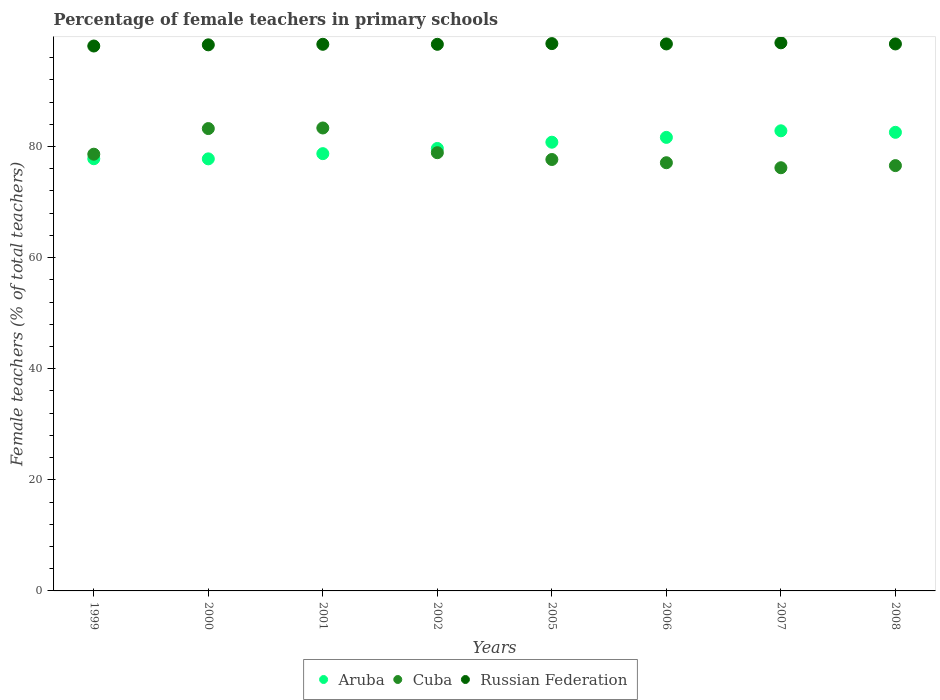Is the number of dotlines equal to the number of legend labels?
Ensure brevity in your answer.  Yes. What is the percentage of female teachers in Aruba in 2005?
Ensure brevity in your answer.  80.78. Across all years, what is the maximum percentage of female teachers in Cuba?
Ensure brevity in your answer.  83.34. Across all years, what is the minimum percentage of female teachers in Aruba?
Your answer should be very brief. 77.78. In which year was the percentage of female teachers in Cuba maximum?
Keep it short and to the point. 2001. What is the total percentage of female teachers in Cuba in the graph?
Provide a succinct answer. 631.56. What is the difference between the percentage of female teachers in Russian Federation in 2002 and that in 2005?
Give a very brief answer. -0.13. What is the difference between the percentage of female teachers in Cuba in 1999 and the percentage of female teachers in Russian Federation in 2005?
Offer a terse response. -19.91. What is the average percentage of female teachers in Russian Federation per year?
Make the answer very short. 98.42. In the year 2000, what is the difference between the percentage of female teachers in Russian Federation and percentage of female teachers in Cuba?
Your answer should be compact. 15.07. In how many years, is the percentage of female teachers in Cuba greater than 88 %?
Your response must be concise. 0. What is the ratio of the percentage of female teachers in Russian Federation in 2002 to that in 2005?
Your answer should be compact. 1. Is the percentage of female teachers in Cuba in 1999 less than that in 2002?
Make the answer very short. Yes. Is the difference between the percentage of female teachers in Russian Federation in 2005 and 2007 greater than the difference between the percentage of female teachers in Cuba in 2005 and 2007?
Offer a terse response. No. What is the difference between the highest and the second highest percentage of female teachers in Cuba?
Your response must be concise. 0.11. What is the difference between the highest and the lowest percentage of female teachers in Aruba?
Give a very brief answer. 5.05. Is the sum of the percentage of female teachers in Russian Federation in 1999 and 2000 greater than the maximum percentage of female teachers in Cuba across all years?
Give a very brief answer. Yes. Is it the case that in every year, the sum of the percentage of female teachers in Russian Federation and percentage of female teachers in Aruba  is greater than the percentage of female teachers in Cuba?
Your answer should be very brief. Yes. Does the percentage of female teachers in Aruba monotonically increase over the years?
Provide a succinct answer. No. Is the percentage of female teachers in Cuba strictly less than the percentage of female teachers in Aruba over the years?
Provide a short and direct response. No. How many dotlines are there?
Offer a very short reply. 3. Does the graph contain any zero values?
Provide a succinct answer. No. What is the title of the graph?
Offer a terse response. Percentage of female teachers in primary schools. What is the label or title of the Y-axis?
Make the answer very short. Female teachers (% of total teachers). What is the Female teachers (% of total teachers) in Aruba in 1999?
Provide a succinct answer. 77.8. What is the Female teachers (% of total teachers) of Cuba in 1999?
Ensure brevity in your answer.  78.62. What is the Female teachers (% of total teachers) in Russian Federation in 1999?
Provide a short and direct response. 98.09. What is the Female teachers (% of total teachers) in Aruba in 2000?
Your answer should be very brief. 77.78. What is the Female teachers (% of total teachers) in Cuba in 2000?
Provide a short and direct response. 83.23. What is the Female teachers (% of total teachers) in Russian Federation in 2000?
Provide a succinct answer. 98.3. What is the Female teachers (% of total teachers) of Aruba in 2001?
Ensure brevity in your answer.  78.71. What is the Female teachers (% of total teachers) of Cuba in 2001?
Offer a terse response. 83.34. What is the Female teachers (% of total teachers) of Russian Federation in 2001?
Provide a short and direct response. 98.4. What is the Female teachers (% of total teachers) of Aruba in 2002?
Your answer should be very brief. 79.65. What is the Female teachers (% of total teachers) of Cuba in 2002?
Your answer should be compact. 78.89. What is the Female teachers (% of total teachers) of Russian Federation in 2002?
Ensure brevity in your answer.  98.4. What is the Female teachers (% of total teachers) in Aruba in 2005?
Offer a very short reply. 80.78. What is the Female teachers (% of total teachers) of Cuba in 2005?
Your response must be concise. 77.66. What is the Female teachers (% of total teachers) in Russian Federation in 2005?
Ensure brevity in your answer.  98.53. What is the Female teachers (% of total teachers) in Aruba in 2006?
Provide a short and direct response. 81.64. What is the Female teachers (% of total teachers) in Cuba in 2006?
Make the answer very short. 77.08. What is the Female teachers (% of total teachers) of Russian Federation in 2006?
Give a very brief answer. 98.47. What is the Female teachers (% of total teachers) in Aruba in 2007?
Your response must be concise. 82.83. What is the Female teachers (% of total teachers) of Cuba in 2007?
Offer a terse response. 76.18. What is the Female teachers (% of total teachers) of Russian Federation in 2007?
Make the answer very short. 98.67. What is the Female teachers (% of total teachers) in Aruba in 2008?
Give a very brief answer. 82.56. What is the Female teachers (% of total teachers) of Cuba in 2008?
Offer a terse response. 76.56. What is the Female teachers (% of total teachers) in Russian Federation in 2008?
Keep it short and to the point. 98.46. Across all years, what is the maximum Female teachers (% of total teachers) of Aruba?
Your answer should be compact. 82.83. Across all years, what is the maximum Female teachers (% of total teachers) of Cuba?
Offer a terse response. 83.34. Across all years, what is the maximum Female teachers (% of total teachers) in Russian Federation?
Your answer should be very brief. 98.67. Across all years, what is the minimum Female teachers (% of total teachers) in Aruba?
Make the answer very short. 77.78. Across all years, what is the minimum Female teachers (% of total teachers) in Cuba?
Your answer should be very brief. 76.18. Across all years, what is the minimum Female teachers (% of total teachers) in Russian Federation?
Keep it short and to the point. 98.09. What is the total Female teachers (% of total teachers) of Aruba in the graph?
Ensure brevity in your answer.  641.75. What is the total Female teachers (% of total teachers) of Cuba in the graph?
Offer a terse response. 631.56. What is the total Female teachers (% of total teachers) in Russian Federation in the graph?
Ensure brevity in your answer.  787.32. What is the difference between the Female teachers (% of total teachers) in Aruba in 1999 and that in 2000?
Your response must be concise. 0.02. What is the difference between the Female teachers (% of total teachers) of Cuba in 1999 and that in 2000?
Offer a terse response. -4.61. What is the difference between the Female teachers (% of total teachers) of Russian Federation in 1999 and that in 2000?
Offer a terse response. -0.21. What is the difference between the Female teachers (% of total teachers) in Aruba in 1999 and that in 2001?
Your answer should be compact. -0.91. What is the difference between the Female teachers (% of total teachers) of Cuba in 1999 and that in 2001?
Your answer should be very brief. -4.72. What is the difference between the Female teachers (% of total teachers) in Russian Federation in 1999 and that in 2001?
Keep it short and to the point. -0.31. What is the difference between the Female teachers (% of total teachers) of Aruba in 1999 and that in 2002?
Provide a succinct answer. -1.85. What is the difference between the Female teachers (% of total teachers) in Cuba in 1999 and that in 2002?
Provide a short and direct response. -0.27. What is the difference between the Female teachers (% of total teachers) of Russian Federation in 1999 and that in 2002?
Make the answer very short. -0.31. What is the difference between the Female teachers (% of total teachers) of Aruba in 1999 and that in 2005?
Offer a very short reply. -2.97. What is the difference between the Female teachers (% of total teachers) in Cuba in 1999 and that in 2005?
Your answer should be compact. 0.96. What is the difference between the Female teachers (% of total teachers) of Russian Federation in 1999 and that in 2005?
Give a very brief answer. -0.43. What is the difference between the Female teachers (% of total teachers) in Aruba in 1999 and that in 2006?
Your response must be concise. -3.84. What is the difference between the Female teachers (% of total teachers) of Cuba in 1999 and that in 2006?
Your response must be concise. 1.54. What is the difference between the Female teachers (% of total teachers) in Russian Federation in 1999 and that in 2006?
Keep it short and to the point. -0.38. What is the difference between the Female teachers (% of total teachers) of Aruba in 1999 and that in 2007?
Offer a terse response. -5.03. What is the difference between the Female teachers (% of total teachers) of Cuba in 1999 and that in 2007?
Offer a very short reply. 2.44. What is the difference between the Female teachers (% of total teachers) of Russian Federation in 1999 and that in 2007?
Your answer should be very brief. -0.57. What is the difference between the Female teachers (% of total teachers) in Aruba in 1999 and that in 2008?
Offer a terse response. -4.75. What is the difference between the Female teachers (% of total teachers) of Cuba in 1999 and that in 2008?
Provide a short and direct response. 2.06. What is the difference between the Female teachers (% of total teachers) of Russian Federation in 1999 and that in 2008?
Your response must be concise. -0.37. What is the difference between the Female teachers (% of total teachers) of Aruba in 2000 and that in 2001?
Your answer should be very brief. -0.94. What is the difference between the Female teachers (% of total teachers) in Cuba in 2000 and that in 2001?
Offer a terse response. -0.11. What is the difference between the Female teachers (% of total teachers) in Russian Federation in 2000 and that in 2001?
Make the answer very short. -0.1. What is the difference between the Female teachers (% of total teachers) of Aruba in 2000 and that in 2002?
Offer a terse response. -1.87. What is the difference between the Female teachers (% of total teachers) in Cuba in 2000 and that in 2002?
Your response must be concise. 4.34. What is the difference between the Female teachers (% of total teachers) in Russian Federation in 2000 and that in 2002?
Give a very brief answer. -0.09. What is the difference between the Female teachers (% of total teachers) in Aruba in 2000 and that in 2005?
Make the answer very short. -3. What is the difference between the Female teachers (% of total teachers) of Cuba in 2000 and that in 2005?
Offer a terse response. 5.57. What is the difference between the Female teachers (% of total teachers) of Russian Federation in 2000 and that in 2005?
Your answer should be very brief. -0.22. What is the difference between the Female teachers (% of total teachers) of Aruba in 2000 and that in 2006?
Provide a short and direct response. -3.87. What is the difference between the Female teachers (% of total teachers) in Cuba in 2000 and that in 2006?
Keep it short and to the point. 6.15. What is the difference between the Female teachers (% of total teachers) in Russian Federation in 2000 and that in 2006?
Provide a short and direct response. -0.16. What is the difference between the Female teachers (% of total teachers) in Aruba in 2000 and that in 2007?
Provide a succinct answer. -5.05. What is the difference between the Female teachers (% of total teachers) in Cuba in 2000 and that in 2007?
Your response must be concise. 7.05. What is the difference between the Female teachers (% of total teachers) in Russian Federation in 2000 and that in 2007?
Provide a succinct answer. -0.36. What is the difference between the Female teachers (% of total teachers) of Aruba in 2000 and that in 2008?
Offer a very short reply. -4.78. What is the difference between the Female teachers (% of total teachers) in Cuba in 2000 and that in 2008?
Make the answer very short. 6.67. What is the difference between the Female teachers (% of total teachers) of Russian Federation in 2000 and that in 2008?
Ensure brevity in your answer.  -0.16. What is the difference between the Female teachers (% of total teachers) of Aruba in 2001 and that in 2002?
Your answer should be very brief. -0.94. What is the difference between the Female teachers (% of total teachers) in Cuba in 2001 and that in 2002?
Keep it short and to the point. 4.45. What is the difference between the Female teachers (% of total teachers) of Russian Federation in 2001 and that in 2002?
Make the answer very short. 0. What is the difference between the Female teachers (% of total teachers) of Aruba in 2001 and that in 2005?
Ensure brevity in your answer.  -2.06. What is the difference between the Female teachers (% of total teachers) of Cuba in 2001 and that in 2005?
Your answer should be very brief. 5.67. What is the difference between the Female teachers (% of total teachers) of Russian Federation in 2001 and that in 2005?
Give a very brief answer. -0.12. What is the difference between the Female teachers (% of total teachers) of Aruba in 2001 and that in 2006?
Ensure brevity in your answer.  -2.93. What is the difference between the Female teachers (% of total teachers) in Cuba in 2001 and that in 2006?
Make the answer very short. 6.26. What is the difference between the Female teachers (% of total teachers) in Russian Federation in 2001 and that in 2006?
Provide a short and direct response. -0.07. What is the difference between the Female teachers (% of total teachers) in Aruba in 2001 and that in 2007?
Make the answer very short. -4.11. What is the difference between the Female teachers (% of total teachers) in Cuba in 2001 and that in 2007?
Provide a succinct answer. 7.16. What is the difference between the Female teachers (% of total teachers) of Russian Federation in 2001 and that in 2007?
Offer a very short reply. -0.26. What is the difference between the Female teachers (% of total teachers) of Aruba in 2001 and that in 2008?
Provide a short and direct response. -3.84. What is the difference between the Female teachers (% of total teachers) in Cuba in 2001 and that in 2008?
Provide a short and direct response. 6.77. What is the difference between the Female teachers (% of total teachers) in Russian Federation in 2001 and that in 2008?
Your response must be concise. -0.06. What is the difference between the Female teachers (% of total teachers) of Aruba in 2002 and that in 2005?
Provide a short and direct response. -1.12. What is the difference between the Female teachers (% of total teachers) of Cuba in 2002 and that in 2005?
Keep it short and to the point. 1.22. What is the difference between the Female teachers (% of total teachers) in Russian Federation in 2002 and that in 2005?
Ensure brevity in your answer.  -0.13. What is the difference between the Female teachers (% of total teachers) in Aruba in 2002 and that in 2006?
Provide a succinct answer. -1.99. What is the difference between the Female teachers (% of total teachers) in Cuba in 2002 and that in 2006?
Make the answer very short. 1.81. What is the difference between the Female teachers (% of total teachers) in Russian Federation in 2002 and that in 2006?
Your answer should be compact. -0.07. What is the difference between the Female teachers (% of total teachers) in Aruba in 2002 and that in 2007?
Offer a very short reply. -3.18. What is the difference between the Female teachers (% of total teachers) of Cuba in 2002 and that in 2007?
Your answer should be compact. 2.71. What is the difference between the Female teachers (% of total teachers) of Russian Federation in 2002 and that in 2007?
Offer a very short reply. -0.27. What is the difference between the Female teachers (% of total teachers) in Aruba in 2002 and that in 2008?
Keep it short and to the point. -2.9. What is the difference between the Female teachers (% of total teachers) in Cuba in 2002 and that in 2008?
Provide a succinct answer. 2.32. What is the difference between the Female teachers (% of total teachers) of Russian Federation in 2002 and that in 2008?
Provide a short and direct response. -0.07. What is the difference between the Female teachers (% of total teachers) of Aruba in 2005 and that in 2006?
Provide a succinct answer. -0.87. What is the difference between the Female teachers (% of total teachers) of Cuba in 2005 and that in 2006?
Make the answer very short. 0.58. What is the difference between the Female teachers (% of total teachers) of Russian Federation in 2005 and that in 2006?
Ensure brevity in your answer.  0.06. What is the difference between the Female teachers (% of total teachers) of Aruba in 2005 and that in 2007?
Keep it short and to the point. -2.05. What is the difference between the Female teachers (% of total teachers) of Cuba in 2005 and that in 2007?
Keep it short and to the point. 1.48. What is the difference between the Female teachers (% of total teachers) in Russian Federation in 2005 and that in 2007?
Your answer should be very brief. -0.14. What is the difference between the Female teachers (% of total teachers) of Aruba in 2005 and that in 2008?
Your response must be concise. -1.78. What is the difference between the Female teachers (% of total teachers) of Cuba in 2005 and that in 2008?
Offer a very short reply. 1.1. What is the difference between the Female teachers (% of total teachers) in Russian Federation in 2005 and that in 2008?
Offer a very short reply. 0.06. What is the difference between the Female teachers (% of total teachers) of Aruba in 2006 and that in 2007?
Offer a very short reply. -1.18. What is the difference between the Female teachers (% of total teachers) in Cuba in 2006 and that in 2007?
Offer a very short reply. 0.9. What is the difference between the Female teachers (% of total teachers) in Russian Federation in 2006 and that in 2007?
Keep it short and to the point. -0.2. What is the difference between the Female teachers (% of total teachers) in Aruba in 2006 and that in 2008?
Give a very brief answer. -0.91. What is the difference between the Female teachers (% of total teachers) of Cuba in 2006 and that in 2008?
Your answer should be very brief. 0.52. What is the difference between the Female teachers (% of total teachers) in Russian Federation in 2006 and that in 2008?
Your response must be concise. 0. What is the difference between the Female teachers (% of total teachers) in Aruba in 2007 and that in 2008?
Offer a terse response. 0.27. What is the difference between the Female teachers (% of total teachers) in Cuba in 2007 and that in 2008?
Offer a very short reply. -0.38. What is the difference between the Female teachers (% of total teachers) of Russian Federation in 2007 and that in 2008?
Your answer should be compact. 0.2. What is the difference between the Female teachers (% of total teachers) of Aruba in 1999 and the Female teachers (% of total teachers) of Cuba in 2000?
Your answer should be compact. -5.43. What is the difference between the Female teachers (% of total teachers) in Aruba in 1999 and the Female teachers (% of total teachers) in Russian Federation in 2000?
Keep it short and to the point. -20.5. What is the difference between the Female teachers (% of total teachers) of Cuba in 1999 and the Female teachers (% of total teachers) of Russian Federation in 2000?
Ensure brevity in your answer.  -19.69. What is the difference between the Female teachers (% of total teachers) of Aruba in 1999 and the Female teachers (% of total teachers) of Cuba in 2001?
Give a very brief answer. -5.54. What is the difference between the Female teachers (% of total teachers) in Aruba in 1999 and the Female teachers (% of total teachers) in Russian Federation in 2001?
Offer a terse response. -20.6. What is the difference between the Female teachers (% of total teachers) of Cuba in 1999 and the Female teachers (% of total teachers) of Russian Federation in 2001?
Your answer should be compact. -19.78. What is the difference between the Female teachers (% of total teachers) of Aruba in 1999 and the Female teachers (% of total teachers) of Cuba in 2002?
Your answer should be compact. -1.09. What is the difference between the Female teachers (% of total teachers) in Aruba in 1999 and the Female teachers (% of total teachers) in Russian Federation in 2002?
Provide a succinct answer. -20.6. What is the difference between the Female teachers (% of total teachers) in Cuba in 1999 and the Female teachers (% of total teachers) in Russian Federation in 2002?
Offer a terse response. -19.78. What is the difference between the Female teachers (% of total teachers) in Aruba in 1999 and the Female teachers (% of total teachers) in Cuba in 2005?
Ensure brevity in your answer.  0.14. What is the difference between the Female teachers (% of total teachers) in Aruba in 1999 and the Female teachers (% of total teachers) in Russian Federation in 2005?
Keep it short and to the point. -20.72. What is the difference between the Female teachers (% of total teachers) in Cuba in 1999 and the Female teachers (% of total teachers) in Russian Federation in 2005?
Your answer should be very brief. -19.91. What is the difference between the Female teachers (% of total teachers) in Aruba in 1999 and the Female teachers (% of total teachers) in Cuba in 2006?
Your answer should be compact. 0.72. What is the difference between the Female teachers (% of total teachers) in Aruba in 1999 and the Female teachers (% of total teachers) in Russian Federation in 2006?
Provide a succinct answer. -20.67. What is the difference between the Female teachers (% of total teachers) in Cuba in 1999 and the Female teachers (% of total teachers) in Russian Federation in 2006?
Ensure brevity in your answer.  -19.85. What is the difference between the Female teachers (% of total teachers) in Aruba in 1999 and the Female teachers (% of total teachers) in Cuba in 2007?
Offer a terse response. 1.62. What is the difference between the Female teachers (% of total teachers) in Aruba in 1999 and the Female teachers (% of total teachers) in Russian Federation in 2007?
Provide a short and direct response. -20.87. What is the difference between the Female teachers (% of total teachers) of Cuba in 1999 and the Female teachers (% of total teachers) of Russian Federation in 2007?
Offer a very short reply. -20.05. What is the difference between the Female teachers (% of total teachers) of Aruba in 1999 and the Female teachers (% of total teachers) of Cuba in 2008?
Your response must be concise. 1.24. What is the difference between the Female teachers (% of total teachers) in Aruba in 1999 and the Female teachers (% of total teachers) in Russian Federation in 2008?
Your answer should be very brief. -20.66. What is the difference between the Female teachers (% of total teachers) in Cuba in 1999 and the Female teachers (% of total teachers) in Russian Federation in 2008?
Offer a very short reply. -19.85. What is the difference between the Female teachers (% of total teachers) in Aruba in 2000 and the Female teachers (% of total teachers) in Cuba in 2001?
Give a very brief answer. -5.56. What is the difference between the Female teachers (% of total teachers) in Aruba in 2000 and the Female teachers (% of total teachers) in Russian Federation in 2001?
Make the answer very short. -20.62. What is the difference between the Female teachers (% of total teachers) in Cuba in 2000 and the Female teachers (% of total teachers) in Russian Federation in 2001?
Make the answer very short. -15.17. What is the difference between the Female teachers (% of total teachers) of Aruba in 2000 and the Female teachers (% of total teachers) of Cuba in 2002?
Offer a very short reply. -1.11. What is the difference between the Female teachers (% of total teachers) of Aruba in 2000 and the Female teachers (% of total teachers) of Russian Federation in 2002?
Your answer should be compact. -20.62. What is the difference between the Female teachers (% of total teachers) in Cuba in 2000 and the Female teachers (% of total teachers) in Russian Federation in 2002?
Give a very brief answer. -15.17. What is the difference between the Female teachers (% of total teachers) of Aruba in 2000 and the Female teachers (% of total teachers) of Cuba in 2005?
Ensure brevity in your answer.  0.12. What is the difference between the Female teachers (% of total teachers) in Aruba in 2000 and the Female teachers (% of total teachers) in Russian Federation in 2005?
Keep it short and to the point. -20.75. What is the difference between the Female teachers (% of total teachers) of Cuba in 2000 and the Female teachers (% of total teachers) of Russian Federation in 2005?
Keep it short and to the point. -15.29. What is the difference between the Female teachers (% of total teachers) of Aruba in 2000 and the Female teachers (% of total teachers) of Cuba in 2006?
Provide a succinct answer. 0.7. What is the difference between the Female teachers (% of total teachers) in Aruba in 2000 and the Female teachers (% of total teachers) in Russian Federation in 2006?
Make the answer very short. -20.69. What is the difference between the Female teachers (% of total teachers) in Cuba in 2000 and the Female teachers (% of total teachers) in Russian Federation in 2006?
Your answer should be very brief. -15.24. What is the difference between the Female teachers (% of total teachers) in Aruba in 2000 and the Female teachers (% of total teachers) in Cuba in 2007?
Offer a very short reply. 1.6. What is the difference between the Female teachers (% of total teachers) in Aruba in 2000 and the Female teachers (% of total teachers) in Russian Federation in 2007?
Give a very brief answer. -20.89. What is the difference between the Female teachers (% of total teachers) in Cuba in 2000 and the Female teachers (% of total teachers) in Russian Federation in 2007?
Offer a terse response. -15.44. What is the difference between the Female teachers (% of total teachers) in Aruba in 2000 and the Female teachers (% of total teachers) in Cuba in 2008?
Provide a succinct answer. 1.21. What is the difference between the Female teachers (% of total teachers) of Aruba in 2000 and the Female teachers (% of total teachers) of Russian Federation in 2008?
Provide a succinct answer. -20.69. What is the difference between the Female teachers (% of total teachers) in Cuba in 2000 and the Female teachers (% of total teachers) in Russian Federation in 2008?
Make the answer very short. -15.23. What is the difference between the Female teachers (% of total teachers) of Aruba in 2001 and the Female teachers (% of total teachers) of Cuba in 2002?
Ensure brevity in your answer.  -0.17. What is the difference between the Female teachers (% of total teachers) of Aruba in 2001 and the Female teachers (% of total teachers) of Russian Federation in 2002?
Provide a succinct answer. -19.68. What is the difference between the Female teachers (% of total teachers) of Cuba in 2001 and the Female teachers (% of total teachers) of Russian Federation in 2002?
Give a very brief answer. -15.06. What is the difference between the Female teachers (% of total teachers) of Aruba in 2001 and the Female teachers (% of total teachers) of Cuba in 2005?
Provide a succinct answer. 1.05. What is the difference between the Female teachers (% of total teachers) in Aruba in 2001 and the Female teachers (% of total teachers) in Russian Federation in 2005?
Offer a very short reply. -19.81. What is the difference between the Female teachers (% of total teachers) in Cuba in 2001 and the Female teachers (% of total teachers) in Russian Federation in 2005?
Keep it short and to the point. -15.19. What is the difference between the Female teachers (% of total teachers) in Aruba in 2001 and the Female teachers (% of total teachers) in Cuba in 2006?
Ensure brevity in your answer.  1.63. What is the difference between the Female teachers (% of total teachers) in Aruba in 2001 and the Female teachers (% of total teachers) in Russian Federation in 2006?
Give a very brief answer. -19.75. What is the difference between the Female teachers (% of total teachers) of Cuba in 2001 and the Female teachers (% of total teachers) of Russian Federation in 2006?
Offer a terse response. -15.13. What is the difference between the Female teachers (% of total teachers) of Aruba in 2001 and the Female teachers (% of total teachers) of Cuba in 2007?
Keep it short and to the point. 2.54. What is the difference between the Female teachers (% of total teachers) of Aruba in 2001 and the Female teachers (% of total teachers) of Russian Federation in 2007?
Offer a terse response. -19.95. What is the difference between the Female teachers (% of total teachers) in Cuba in 2001 and the Female teachers (% of total teachers) in Russian Federation in 2007?
Your answer should be very brief. -15.33. What is the difference between the Female teachers (% of total teachers) in Aruba in 2001 and the Female teachers (% of total teachers) in Cuba in 2008?
Make the answer very short. 2.15. What is the difference between the Female teachers (% of total teachers) of Aruba in 2001 and the Female teachers (% of total teachers) of Russian Federation in 2008?
Ensure brevity in your answer.  -19.75. What is the difference between the Female teachers (% of total teachers) in Cuba in 2001 and the Female teachers (% of total teachers) in Russian Federation in 2008?
Your answer should be compact. -15.13. What is the difference between the Female teachers (% of total teachers) of Aruba in 2002 and the Female teachers (% of total teachers) of Cuba in 2005?
Provide a succinct answer. 1.99. What is the difference between the Female teachers (% of total teachers) in Aruba in 2002 and the Female teachers (% of total teachers) in Russian Federation in 2005?
Make the answer very short. -18.87. What is the difference between the Female teachers (% of total teachers) of Cuba in 2002 and the Female teachers (% of total teachers) of Russian Federation in 2005?
Ensure brevity in your answer.  -19.64. What is the difference between the Female teachers (% of total teachers) of Aruba in 2002 and the Female teachers (% of total teachers) of Cuba in 2006?
Ensure brevity in your answer.  2.57. What is the difference between the Female teachers (% of total teachers) of Aruba in 2002 and the Female teachers (% of total teachers) of Russian Federation in 2006?
Keep it short and to the point. -18.82. What is the difference between the Female teachers (% of total teachers) of Cuba in 2002 and the Female teachers (% of total teachers) of Russian Federation in 2006?
Offer a terse response. -19.58. What is the difference between the Female teachers (% of total teachers) in Aruba in 2002 and the Female teachers (% of total teachers) in Cuba in 2007?
Ensure brevity in your answer.  3.47. What is the difference between the Female teachers (% of total teachers) of Aruba in 2002 and the Female teachers (% of total teachers) of Russian Federation in 2007?
Ensure brevity in your answer.  -19.02. What is the difference between the Female teachers (% of total teachers) in Cuba in 2002 and the Female teachers (% of total teachers) in Russian Federation in 2007?
Ensure brevity in your answer.  -19.78. What is the difference between the Female teachers (% of total teachers) of Aruba in 2002 and the Female teachers (% of total teachers) of Cuba in 2008?
Provide a short and direct response. 3.09. What is the difference between the Female teachers (% of total teachers) of Aruba in 2002 and the Female teachers (% of total teachers) of Russian Federation in 2008?
Keep it short and to the point. -18.81. What is the difference between the Female teachers (% of total teachers) in Cuba in 2002 and the Female teachers (% of total teachers) in Russian Federation in 2008?
Ensure brevity in your answer.  -19.58. What is the difference between the Female teachers (% of total teachers) in Aruba in 2005 and the Female teachers (% of total teachers) in Cuba in 2006?
Ensure brevity in your answer.  3.69. What is the difference between the Female teachers (% of total teachers) of Aruba in 2005 and the Female teachers (% of total teachers) of Russian Federation in 2006?
Offer a very short reply. -17.69. What is the difference between the Female teachers (% of total teachers) in Cuba in 2005 and the Female teachers (% of total teachers) in Russian Federation in 2006?
Your answer should be very brief. -20.81. What is the difference between the Female teachers (% of total teachers) in Aruba in 2005 and the Female teachers (% of total teachers) in Cuba in 2007?
Make the answer very short. 4.6. What is the difference between the Female teachers (% of total teachers) of Aruba in 2005 and the Female teachers (% of total teachers) of Russian Federation in 2007?
Your answer should be compact. -17.89. What is the difference between the Female teachers (% of total teachers) in Cuba in 2005 and the Female teachers (% of total teachers) in Russian Federation in 2007?
Your answer should be very brief. -21. What is the difference between the Female teachers (% of total teachers) in Aruba in 2005 and the Female teachers (% of total teachers) in Cuba in 2008?
Your response must be concise. 4.21. What is the difference between the Female teachers (% of total teachers) in Aruba in 2005 and the Female teachers (% of total teachers) in Russian Federation in 2008?
Keep it short and to the point. -17.69. What is the difference between the Female teachers (% of total teachers) in Cuba in 2005 and the Female teachers (% of total teachers) in Russian Federation in 2008?
Your answer should be compact. -20.8. What is the difference between the Female teachers (% of total teachers) of Aruba in 2006 and the Female teachers (% of total teachers) of Cuba in 2007?
Provide a short and direct response. 5.47. What is the difference between the Female teachers (% of total teachers) in Aruba in 2006 and the Female teachers (% of total teachers) in Russian Federation in 2007?
Offer a terse response. -17.02. What is the difference between the Female teachers (% of total teachers) in Cuba in 2006 and the Female teachers (% of total teachers) in Russian Federation in 2007?
Your answer should be compact. -21.59. What is the difference between the Female teachers (% of total teachers) of Aruba in 2006 and the Female teachers (% of total teachers) of Cuba in 2008?
Offer a terse response. 5.08. What is the difference between the Female teachers (% of total teachers) of Aruba in 2006 and the Female teachers (% of total teachers) of Russian Federation in 2008?
Your response must be concise. -16.82. What is the difference between the Female teachers (% of total teachers) in Cuba in 2006 and the Female teachers (% of total teachers) in Russian Federation in 2008?
Keep it short and to the point. -21.38. What is the difference between the Female teachers (% of total teachers) of Aruba in 2007 and the Female teachers (% of total teachers) of Cuba in 2008?
Offer a terse response. 6.27. What is the difference between the Female teachers (% of total teachers) of Aruba in 2007 and the Female teachers (% of total teachers) of Russian Federation in 2008?
Your answer should be compact. -15.64. What is the difference between the Female teachers (% of total teachers) of Cuba in 2007 and the Female teachers (% of total teachers) of Russian Federation in 2008?
Offer a terse response. -22.29. What is the average Female teachers (% of total teachers) of Aruba per year?
Your answer should be compact. 80.22. What is the average Female teachers (% of total teachers) of Cuba per year?
Your answer should be compact. 78.94. What is the average Female teachers (% of total teachers) in Russian Federation per year?
Make the answer very short. 98.42. In the year 1999, what is the difference between the Female teachers (% of total teachers) in Aruba and Female teachers (% of total teachers) in Cuba?
Your answer should be compact. -0.82. In the year 1999, what is the difference between the Female teachers (% of total teachers) in Aruba and Female teachers (% of total teachers) in Russian Federation?
Your answer should be very brief. -20.29. In the year 1999, what is the difference between the Female teachers (% of total teachers) in Cuba and Female teachers (% of total teachers) in Russian Federation?
Make the answer very short. -19.47. In the year 2000, what is the difference between the Female teachers (% of total teachers) in Aruba and Female teachers (% of total teachers) in Cuba?
Offer a terse response. -5.45. In the year 2000, what is the difference between the Female teachers (% of total teachers) of Aruba and Female teachers (% of total teachers) of Russian Federation?
Offer a terse response. -20.53. In the year 2000, what is the difference between the Female teachers (% of total teachers) of Cuba and Female teachers (% of total teachers) of Russian Federation?
Provide a short and direct response. -15.07. In the year 2001, what is the difference between the Female teachers (% of total teachers) of Aruba and Female teachers (% of total teachers) of Cuba?
Your answer should be compact. -4.62. In the year 2001, what is the difference between the Female teachers (% of total teachers) of Aruba and Female teachers (% of total teachers) of Russian Federation?
Give a very brief answer. -19.69. In the year 2001, what is the difference between the Female teachers (% of total teachers) of Cuba and Female teachers (% of total teachers) of Russian Federation?
Your answer should be compact. -15.07. In the year 2002, what is the difference between the Female teachers (% of total teachers) of Aruba and Female teachers (% of total teachers) of Cuba?
Keep it short and to the point. 0.76. In the year 2002, what is the difference between the Female teachers (% of total teachers) in Aruba and Female teachers (% of total teachers) in Russian Federation?
Keep it short and to the point. -18.75. In the year 2002, what is the difference between the Female teachers (% of total teachers) in Cuba and Female teachers (% of total teachers) in Russian Federation?
Your answer should be very brief. -19.51. In the year 2005, what is the difference between the Female teachers (% of total teachers) of Aruba and Female teachers (% of total teachers) of Cuba?
Your answer should be very brief. 3.11. In the year 2005, what is the difference between the Female teachers (% of total teachers) of Aruba and Female teachers (% of total teachers) of Russian Federation?
Ensure brevity in your answer.  -17.75. In the year 2005, what is the difference between the Female teachers (% of total teachers) of Cuba and Female teachers (% of total teachers) of Russian Federation?
Provide a succinct answer. -20.86. In the year 2006, what is the difference between the Female teachers (% of total teachers) of Aruba and Female teachers (% of total teachers) of Cuba?
Provide a short and direct response. 4.56. In the year 2006, what is the difference between the Female teachers (% of total teachers) of Aruba and Female teachers (% of total teachers) of Russian Federation?
Ensure brevity in your answer.  -16.82. In the year 2006, what is the difference between the Female teachers (% of total teachers) of Cuba and Female teachers (% of total teachers) of Russian Federation?
Provide a succinct answer. -21.39. In the year 2007, what is the difference between the Female teachers (% of total teachers) in Aruba and Female teachers (% of total teachers) in Cuba?
Ensure brevity in your answer.  6.65. In the year 2007, what is the difference between the Female teachers (% of total teachers) in Aruba and Female teachers (% of total teachers) in Russian Federation?
Offer a very short reply. -15.84. In the year 2007, what is the difference between the Female teachers (% of total teachers) in Cuba and Female teachers (% of total teachers) in Russian Federation?
Provide a succinct answer. -22.49. In the year 2008, what is the difference between the Female teachers (% of total teachers) in Aruba and Female teachers (% of total teachers) in Cuba?
Your answer should be very brief. 5.99. In the year 2008, what is the difference between the Female teachers (% of total teachers) in Aruba and Female teachers (% of total teachers) in Russian Federation?
Keep it short and to the point. -15.91. In the year 2008, what is the difference between the Female teachers (% of total teachers) in Cuba and Female teachers (% of total teachers) in Russian Federation?
Your answer should be compact. -21.9. What is the ratio of the Female teachers (% of total teachers) of Aruba in 1999 to that in 2000?
Provide a succinct answer. 1. What is the ratio of the Female teachers (% of total teachers) of Cuba in 1999 to that in 2000?
Provide a succinct answer. 0.94. What is the ratio of the Female teachers (% of total teachers) in Russian Federation in 1999 to that in 2000?
Make the answer very short. 1. What is the ratio of the Female teachers (% of total teachers) in Aruba in 1999 to that in 2001?
Your answer should be very brief. 0.99. What is the ratio of the Female teachers (% of total teachers) of Cuba in 1999 to that in 2001?
Make the answer very short. 0.94. What is the ratio of the Female teachers (% of total teachers) in Russian Federation in 1999 to that in 2001?
Offer a very short reply. 1. What is the ratio of the Female teachers (% of total teachers) in Aruba in 1999 to that in 2002?
Keep it short and to the point. 0.98. What is the ratio of the Female teachers (% of total teachers) in Russian Federation in 1999 to that in 2002?
Provide a short and direct response. 1. What is the ratio of the Female teachers (% of total teachers) in Aruba in 1999 to that in 2005?
Offer a terse response. 0.96. What is the ratio of the Female teachers (% of total teachers) of Cuba in 1999 to that in 2005?
Provide a short and direct response. 1.01. What is the ratio of the Female teachers (% of total teachers) in Russian Federation in 1999 to that in 2005?
Make the answer very short. 1. What is the ratio of the Female teachers (% of total teachers) in Aruba in 1999 to that in 2006?
Make the answer very short. 0.95. What is the ratio of the Female teachers (% of total teachers) of Cuba in 1999 to that in 2006?
Keep it short and to the point. 1.02. What is the ratio of the Female teachers (% of total teachers) of Aruba in 1999 to that in 2007?
Provide a short and direct response. 0.94. What is the ratio of the Female teachers (% of total teachers) of Cuba in 1999 to that in 2007?
Your answer should be compact. 1.03. What is the ratio of the Female teachers (% of total teachers) of Russian Federation in 1999 to that in 2007?
Offer a terse response. 0.99. What is the ratio of the Female teachers (% of total teachers) of Aruba in 1999 to that in 2008?
Ensure brevity in your answer.  0.94. What is the ratio of the Female teachers (% of total teachers) in Cuba in 1999 to that in 2008?
Offer a terse response. 1.03. What is the ratio of the Female teachers (% of total teachers) of Russian Federation in 1999 to that in 2008?
Ensure brevity in your answer.  1. What is the ratio of the Female teachers (% of total teachers) of Aruba in 2000 to that in 2001?
Provide a short and direct response. 0.99. What is the ratio of the Female teachers (% of total teachers) of Cuba in 2000 to that in 2001?
Offer a terse response. 1. What is the ratio of the Female teachers (% of total teachers) in Russian Federation in 2000 to that in 2001?
Provide a succinct answer. 1. What is the ratio of the Female teachers (% of total teachers) of Aruba in 2000 to that in 2002?
Provide a succinct answer. 0.98. What is the ratio of the Female teachers (% of total teachers) of Cuba in 2000 to that in 2002?
Provide a succinct answer. 1.06. What is the ratio of the Female teachers (% of total teachers) of Russian Federation in 2000 to that in 2002?
Your answer should be very brief. 1. What is the ratio of the Female teachers (% of total teachers) of Aruba in 2000 to that in 2005?
Your answer should be very brief. 0.96. What is the ratio of the Female teachers (% of total teachers) of Cuba in 2000 to that in 2005?
Provide a short and direct response. 1.07. What is the ratio of the Female teachers (% of total teachers) in Russian Federation in 2000 to that in 2005?
Your response must be concise. 1. What is the ratio of the Female teachers (% of total teachers) in Aruba in 2000 to that in 2006?
Provide a short and direct response. 0.95. What is the ratio of the Female teachers (% of total teachers) of Cuba in 2000 to that in 2006?
Ensure brevity in your answer.  1.08. What is the ratio of the Female teachers (% of total teachers) of Aruba in 2000 to that in 2007?
Offer a very short reply. 0.94. What is the ratio of the Female teachers (% of total teachers) of Cuba in 2000 to that in 2007?
Make the answer very short. 1.09. What is the ratio of the Female teachers (% of total teachers) of Aruba in 2000 to that in 2008?
Your response must be concise. 0.94. What is the ratio of the Female teachers (% of total teachers) in Cuba in 2000 to that in 2008?
Offer a terse response. 1.09. What is the ratio of the Female teachers (% of total teachers) of Cuba in 2001 to that in 2002?
Keep it short and to the point. 1.06. What is the ratio of the Female teachers (% of total teachers) of Aruba in 2001 to that in 2005?
Give a very brief answer. 0.97. What is the ratio of the Female teachers (% of total teachers) of Cuba in 2001 to that in 2005?
Give a very brief answer. 1.07. What is the ratio of the Female teachers (% of total teachers) of Aruba in 2001 to that in 2006?
Provide a succinct answer. 0.96. What is the ratio of the Female teachers (% of total teachers) in Cuba in 2001 to that in 2006?
Offer a very short reply. 1.08. What is the ratio of the Female teachers (% of total teachers) in Russian Federation in 2001 to that in 2006?
Give a very brief answer. 1. What is the ratio of the Female teachers (% of total teachers) of Aruba in 2001 to that in 2007?
Make the answer very short. 0.95. What is the ratio of the Female teachers (% of total teachers) of Cuba in 2001 to that in 2007?
Provide a succinct answer. 1.09. What is the ratio of the Female teachers (% of total teachers) of Aruba in 2001 to that in 2008?
Your response must be concise. 0.95. What is the ratio of the Female teachers (% of total teachers) in Cuba in 2001 to that in 2008?
Make the answer very short. 1.09. What is the ratio of the Female teachers (% of total teachers) in Aruba in 2002 to that in 2005?
Your answer should be very brief. 0.99. What is the ratio of the Female teachers (% of total teachers) of Cuba in 2002 to that in 2005?
Give a very brief answer. 1.02. What is the ratio of the Female teachers (% of total teachers) of Russian Federation in 2002 to that in 2005?
Make the answer very short. 1. What is the ratio of the Female teachers (% of total teachers) of Aruba in 2002 to that in 2006?
Make the answer very short. 0.98. What is the ratio of the Female teachers (% of total teachers) of Cuba in 2002 to that in 2006?
Give a very brief answer. 1.02. What is the ratio of the Female teachers (% of total teachers) of Russian Federation in 2002 to that in 2006?
Your answer should be very brief. 1. What is the ratio of the Female teachers (% of total teachers) in Aruba in 2002 to that in 2007?
Your response must be concise. 0.96. What is the ratio of the Female teachers (% of total teachers) of Cuba in 2002 to that in 2007?
Give a very brief answer. 1.04. What is the ratio of the Female teachers (% of total teachers) in Russian Federation in 2002 to that in 2007?
Offer a very short reply. 1. What is the ratio of the Female teachers (% of total teachers) in Aruba in 2002 to that in 2008?
Ensure brevity in your answer.  0.96. What is the ratio of the Female teachers (% of total teachers) in Cuba in 2002 to that in 2008?
Ensure brevity in your answer.  1.03. What is the ratio of the Female teachers (% of total teachers) in Russian Federation in 2002 to that in 2008?
Give a very brief answer. 1. What is the ratio of the Female teachers (% of total teachers) of Aruba in 2005 to that in 2006?
Offer a terse response. 0.99. What is the ratio of the Female teachers (% of total teachers) of Cuba in 2005 to that in 2006?
Keep it short and to the point. 1.01. What is the ratio of the Female teachers (% of total teachers) of Aruba in 2005 to that in 2007?
Your answer should be very brief. 0.98. What is the ratio of the Female teachers (% of total teachers) in Cuba in 2005 to that in 2007?
Your answer should be compact. 1.02. What is the ratio of the Female teachers (% of total teachers) in Russian Federation in 2005 to that in 2007?
Your answer should be compact. 1. What is the ratio of the Female teachers (% of total teachers) in Aruba in 2005 to that in 2008?
Ensure brevity in your answer.  0.98. What is the ratio of the Female teachers (% of total teachers) of Cuba in 2005 to that in 2008?
Your response must be concise. 1.01. What is the ratio of the Female teachers (% of total teachers) of Aruba in 2006 to that in 2007?
Ensure brevity in your answer.  0.99. What is the ratio of the Female teachers (% of total teachers) in Cuba in 2006 to that in 2007?
Provide a succinct answer. 1.01. What is the ratio of the Female teachers (% of total teachers) of Russian Federation in 2006 to that in 2007?
Your answer should be compact. 1. What is the ratio of the Female teachers (% of total teachers) in Aruba in 2006 to that in 2008?
Your answer should be compact. 0.99. What is the ratio of the Female teachers (% of total teachers) of Cuba in 2006 to that in 2008?
Give a very brief answer. 1.01. What is the ratio of the Female teachers (% of total teachers) in Aruba in 2007 to that in 2008?
Give a very brief answer. 1. What is the ratio of the Female teachers (% of total teachers) in Cuba in 2007 to that in 2008?
Keep it short and to the point. 0.99. What is the ratio of the Female teachers (% of total teachers) in Russian Federation in 2007 to that in 2008?
Your answer should be compact. 1. What is the difference between the highest and the second highest Female teachers (% of total teachers) in Aruba?
Provide a short and direct response. 0.27. What is the difference between the highest and the second highest Female teachers (% of total teachers) in Cuba?
Offer a very short reply. 0.11. What is the difference between the highest and the second highest Female teachers (% of total teachers) of Russian Federation?
Provide a succinct answer. 0.14. What is the difference between the highest and the lowest Female teachers (% of total teachers) in Aruba?
Offer a terse response. 5.05. What is the difference between the highest and the lowest Female teachers (% of total teachers) of Cuba?
Ensure brevity in your answer.  7.16. What is the difference between the highest and the lowest Female teachers (% of total teachers) in Russian Federation?
Offer a very short reply. 0.57. 